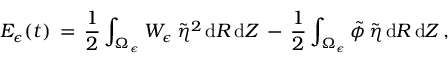<formula> <loc_0><loc_0><loc_500><loc_500>E _ { \epsilon } ( t ) \, = \, \frac { 1 } { 2 } \int _ { \Omega _ { \epsilon } } W _ { \epsilon } \, \tilde { \eta } ^ { 2 } \, d R \, d Z \, - \, \frac { 1 } { 2 } \int _ { \Omega _ { \epsilon } } \tilde { \phi } \, \tilde { \eta } \, d R \, d Z \, ,</formula> 